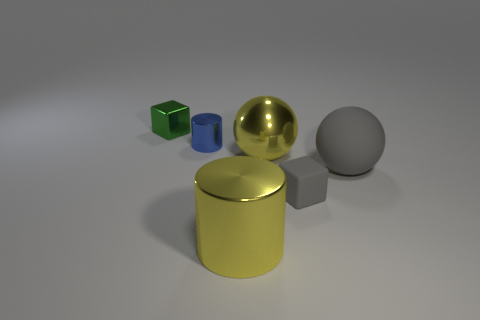The rubber thing that is the same color as the matte block is what size?
Provide a short and direct response. Large. There is a green shiny object; how many tiny blue shiny objects are behind it?
Offer a terse response. 0. There is a block to the left of the block in front of the big ball on the left side of the large gray ball; what size is it?
Ensure brevity in your answer.  Small. Is there a small block on the right side of the big yellow object that is in front of the yellow metal object that is on the right side of the large cylinder?
Your response must be concise. Yes. Is the number of large matte spheres greater than the number of shiny cylinders?
Your answer should be very brief. No. What color is the sphere on the left side of the gray ball?
Keep it short and to the point. Yellow. Are there more small metal objects that are in front of the green shiny cube than tiny purple shiny cylinders?
Offer a very short reply. Yes. Does the big yellow ball have the same material as the large cylinder?
Keep it short and to the point. Yes. How many other objects are the same shape as the large gray thing?
Your answer should be very brief. 1. There is a metallic cylinder in front of the big metallic object that is behind the metal cylinder on the right side of the small metal cylinder; what color is it?
Your response must be concise. Yellow. 